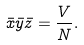<formula> <loc_0><loc_0><loc_500><loc_500>\bar { x } \bar { y } \bar { z } = \frac { V } { N } .</formula> 